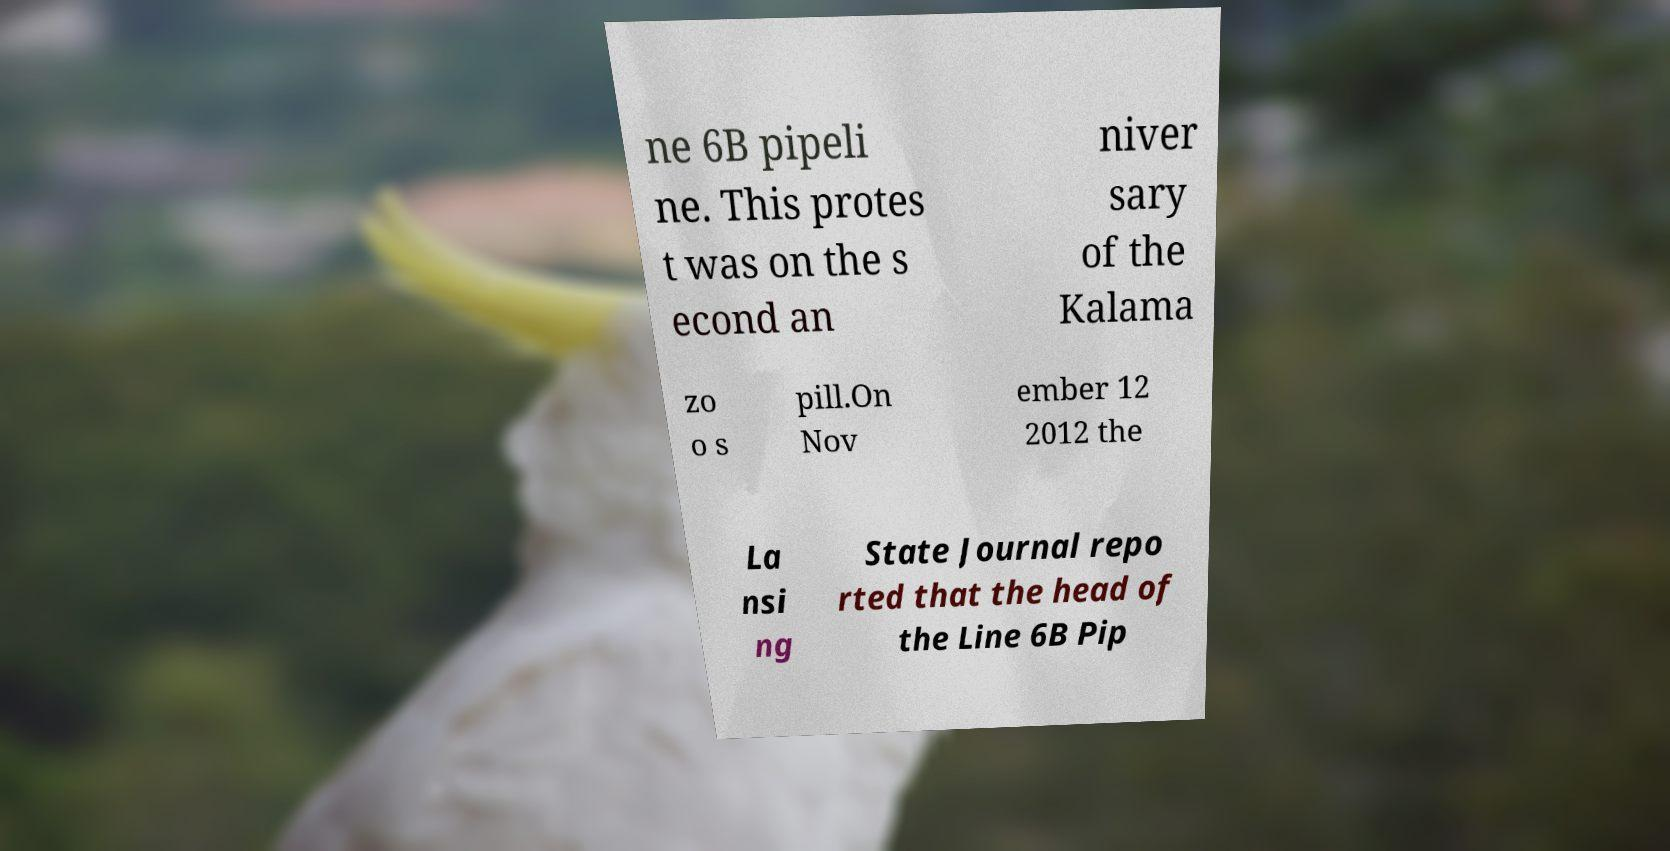I need the written content from this picture converted into text. Can you do that? ne 6B pipeli ne. This protes t was on the s econd an niver sary of the Kalama zo o s pill.On Nov ember 12 2012 the La nsi ng State Journal repo rted that the head of the Line 6B Pip 